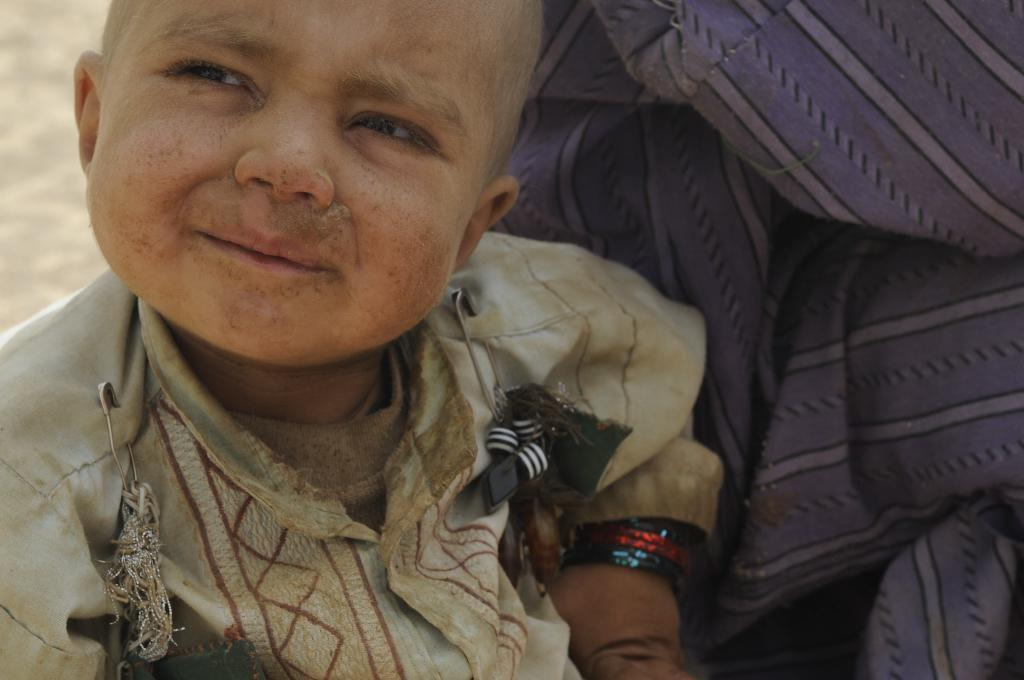What is the main subject of the image? The main subject of the image is a small kid. How does the kid's dress appear in the image? The kid's dress is dusty in the image. Is there any dust on the kid? Yes, there is dust on the kid in the image. What is located beside the kid? There is a cloth beside the kid in the image. What safety features are present on the kid's dress? The kid's dress has two safety features. What caused the match to ignite in the image? There is no match present in the image, so it is not possible to determine the cause of ignition. 